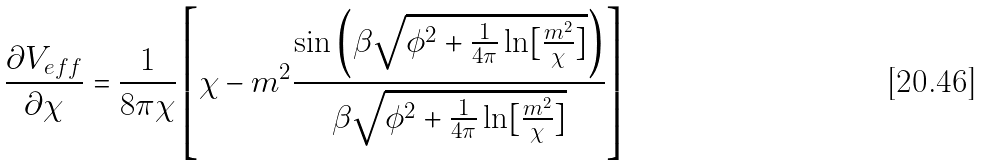<formula> <loc_0><loc_0><loc_500><loc_500>\frac { \partial V _ { e f f } } { \partial \chi } = \frac { 1 } { 8 \pi \chi } \left [ \chi - { m ^ { 2 } } \frac { \sin \left ( \beta \sqrt { \phi ^ { 2 } + \frac { 1 } { 4 \pi } \ln [ \frac { m ^ { 2 } } { \chi } ] } \right ) } { \beta \sqrt { \phi ^ { 2 } + \frac { 1 } { 4 \pi } \ln [ \frac { m ^ { 2 } } { \chi } ] } } \right ]</formula> 